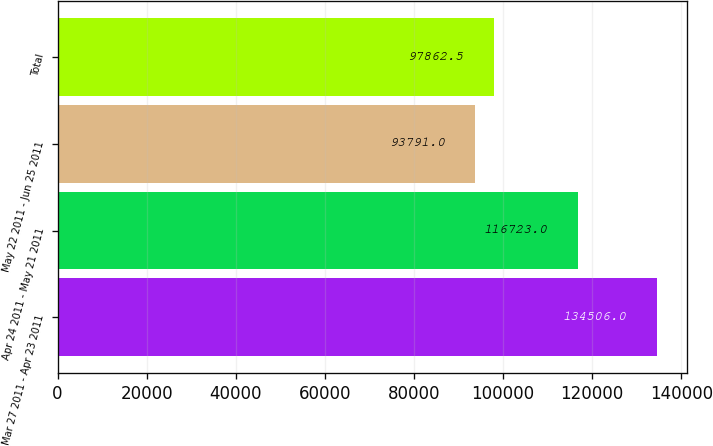Convert chart to OTSL. <chart><loc_0><loc_0><loc_500><loc_500><bar_chart><fcel>Mar 27 2011 - Apr 23 2011<fcel>Apr 24 2011 - May 21 2011<fcel>May 22 2011 - Jun 25 2011<fcel>Total<nl><fcel>134506<fcel>116723<fcel>93791<fcel>97862.5<nl></chart> 